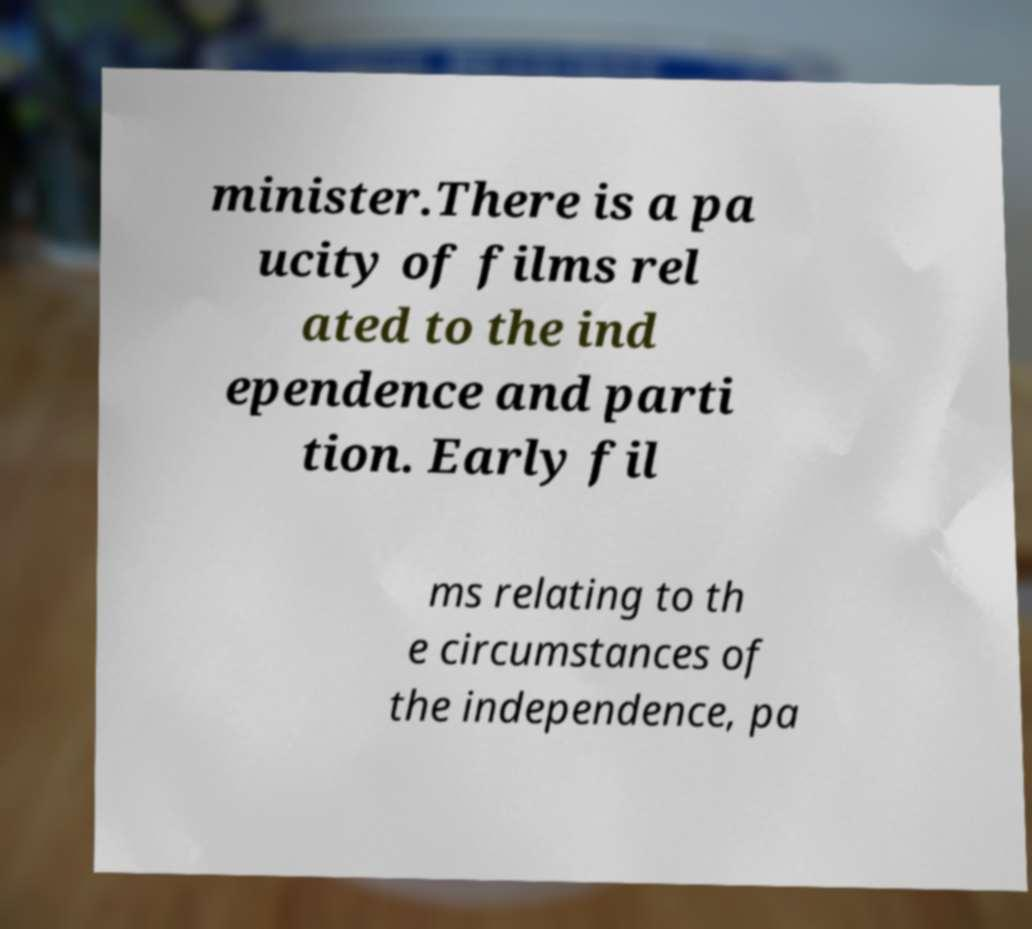Please identify and transcribe the text found in this image. minister.There is a pa ucity of films rel ated to the ind ependence and parti tion. Early fil ms relating to th e circumstances of the independence, pa 